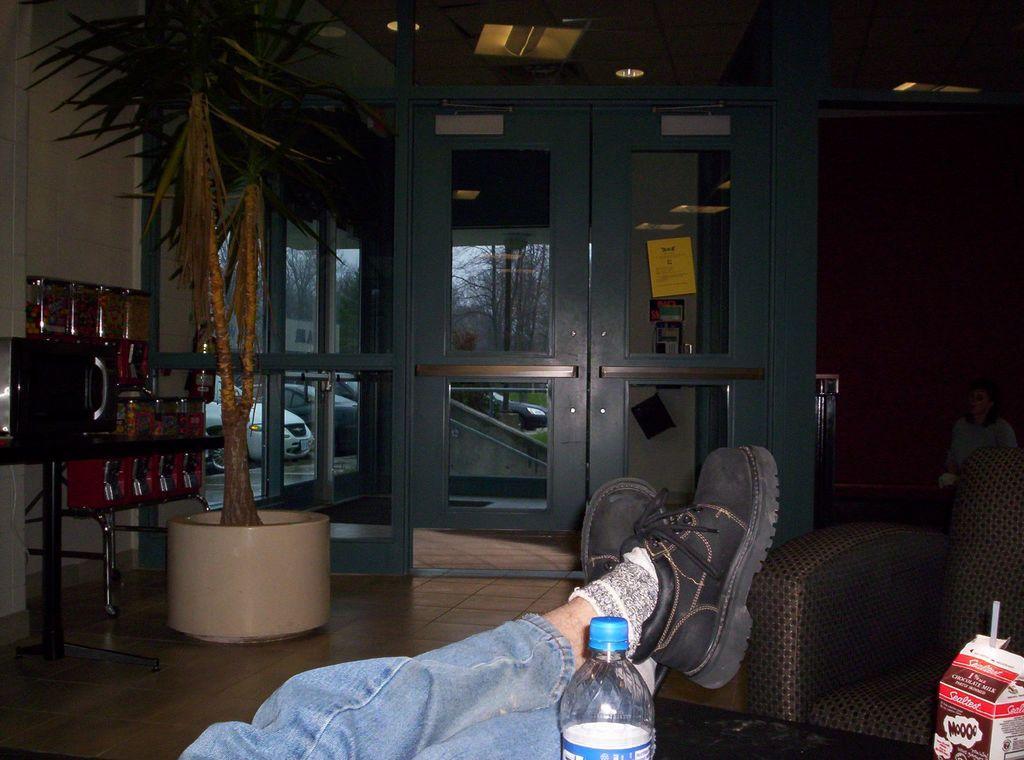Please provide a concise description of this image. In this picture there is a person , bottle, box and a straw on the table. To the right, There is a chair and a woman. To the left, there is a flower pot and plant. In the middle, there is a door and a yellow paper on it. There are lights on the top. Some trees and cars are visible in the background. 